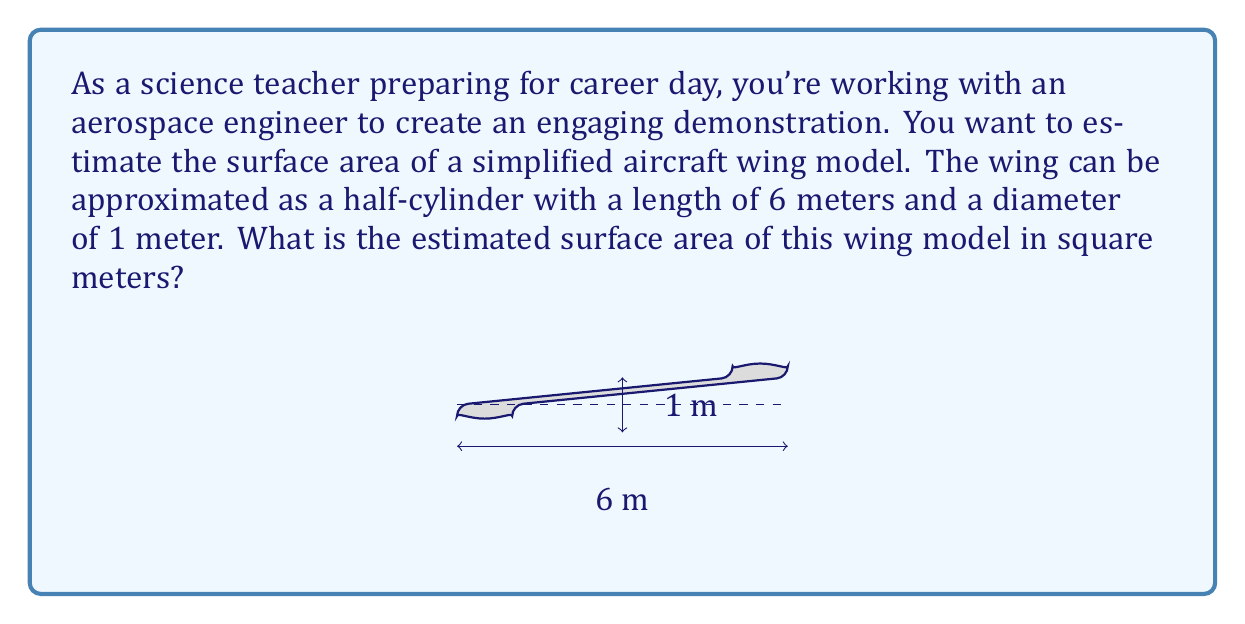Help me with this question. Let's approach this step-by-step:

1) The surface area of a half-cylinder consists of three parts:
   a) The curved surface (half of a full cylinder's lateral area)
   b) The flat rectangular base
   c) The circular end caps (two half-circles)

2) For a cylinder with radius $r$ and length $l$:
   a) Curved surface area: $\frac{1}{2} \cdot 2\pi r l = \pi r l$
   b) Rectangular base area: $l \cdot 2r$
   c) End caps area: $2 \cdot \frac{1}{2} \pi r^2 = \pi r^2$

3) Given dimensions:
   Length $(l) = 6$ m
   Diameter $= 1$ m, so radius $(r) = 0.5$ m

4) Let's calculate each part:
   a) Curved surface: $A_{curved} = \pi r l = \pi \cdot 0.5 \cdot 6 = 3\pi$ m²
   b) Rectangular base: $A_{rect} = l \cdot 2r = 6 \cdot 1 = 6$ m²
   c) End caps: $A_{ends} = \pi r^2 = \pi \cdot 0.5^2 = 0.25\pi$ m²

5) Total surface area:
   $A_{total} = A_{curved} + A_{rect} + A_{ends}$
   $A_{total} = 3\pi + 6 + 0.25\pi = 3.25\pi + 6$ m²

6) Calculating the final value:
   $A_{total} = 3.25 \cdot 3.14159 + 6 \approx 16.21$ m²
Answer: $16.21$ m² 